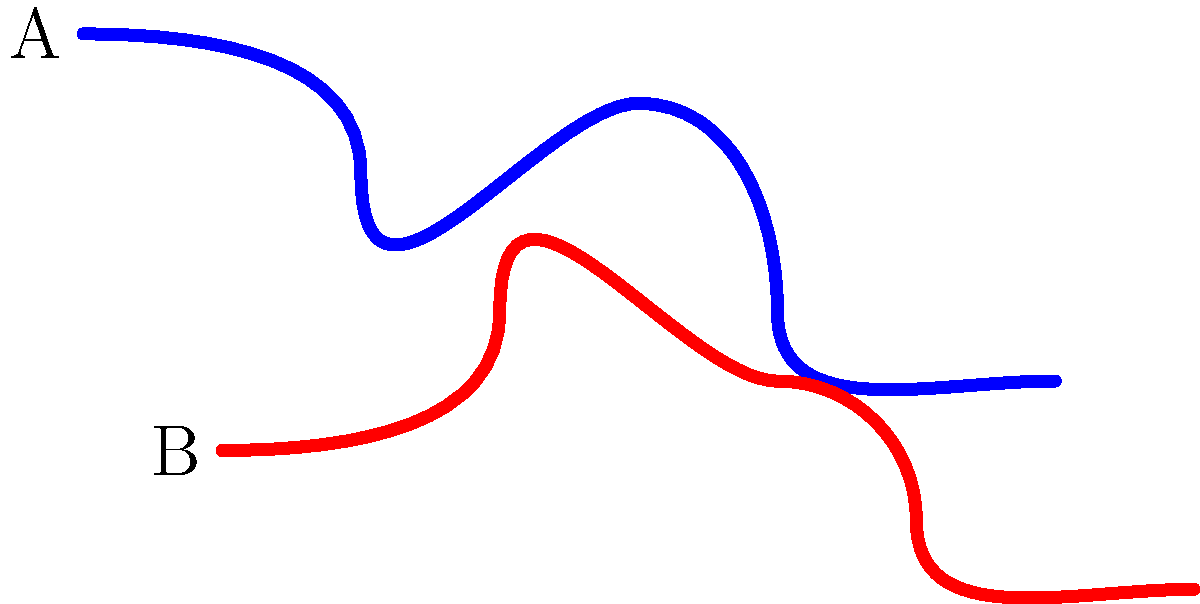Which of the two handwriting styles shown in the image is more characteristic of Karl Hyde's unique style used in Underworld's visual art? To identify Karl Hyde's unique handwriting style, we need to consider the following characteristics:

1. Fluidity: Karl Hyde's handwriting is known for its fluid, continuous strokes.
2. Asymmetry: His style often features asymmetrical, organic forms.
3. Verticality: Hyde's writing tends to have a vertical emphasis, with letters often stretched vertically.
4. Abstraction: The writing often verges on abstraction, sometimes making individual letters difficult to discern.

Analyzing the two styles presented:

Style A (blue):
- More fluid and continuous
- Shows asymmetrical, organic forms
- Has a stronger vertical emphasis
- Appears more abstract and less legible

Style B (red):
- More structured and less fluid
- Shows more symmetry and regularity
- Has a more horizontal emphasis
- Appears more legible and less abstract

Based on these observations, Style A (blue) aligns more closely with Karl Hyde's characteristic handwriting style used in Underworld's visual art.
Answer: A (blue) 